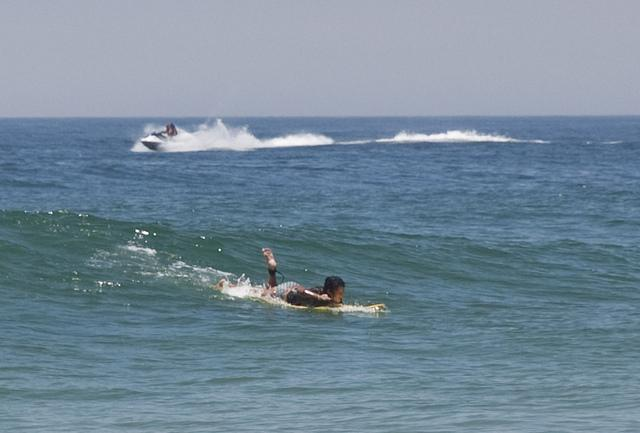Which person seen here goes faster over time? Please explain your reasoning. boat. Boats are powered by a gasoline motor. the person on the board is just using their body. 